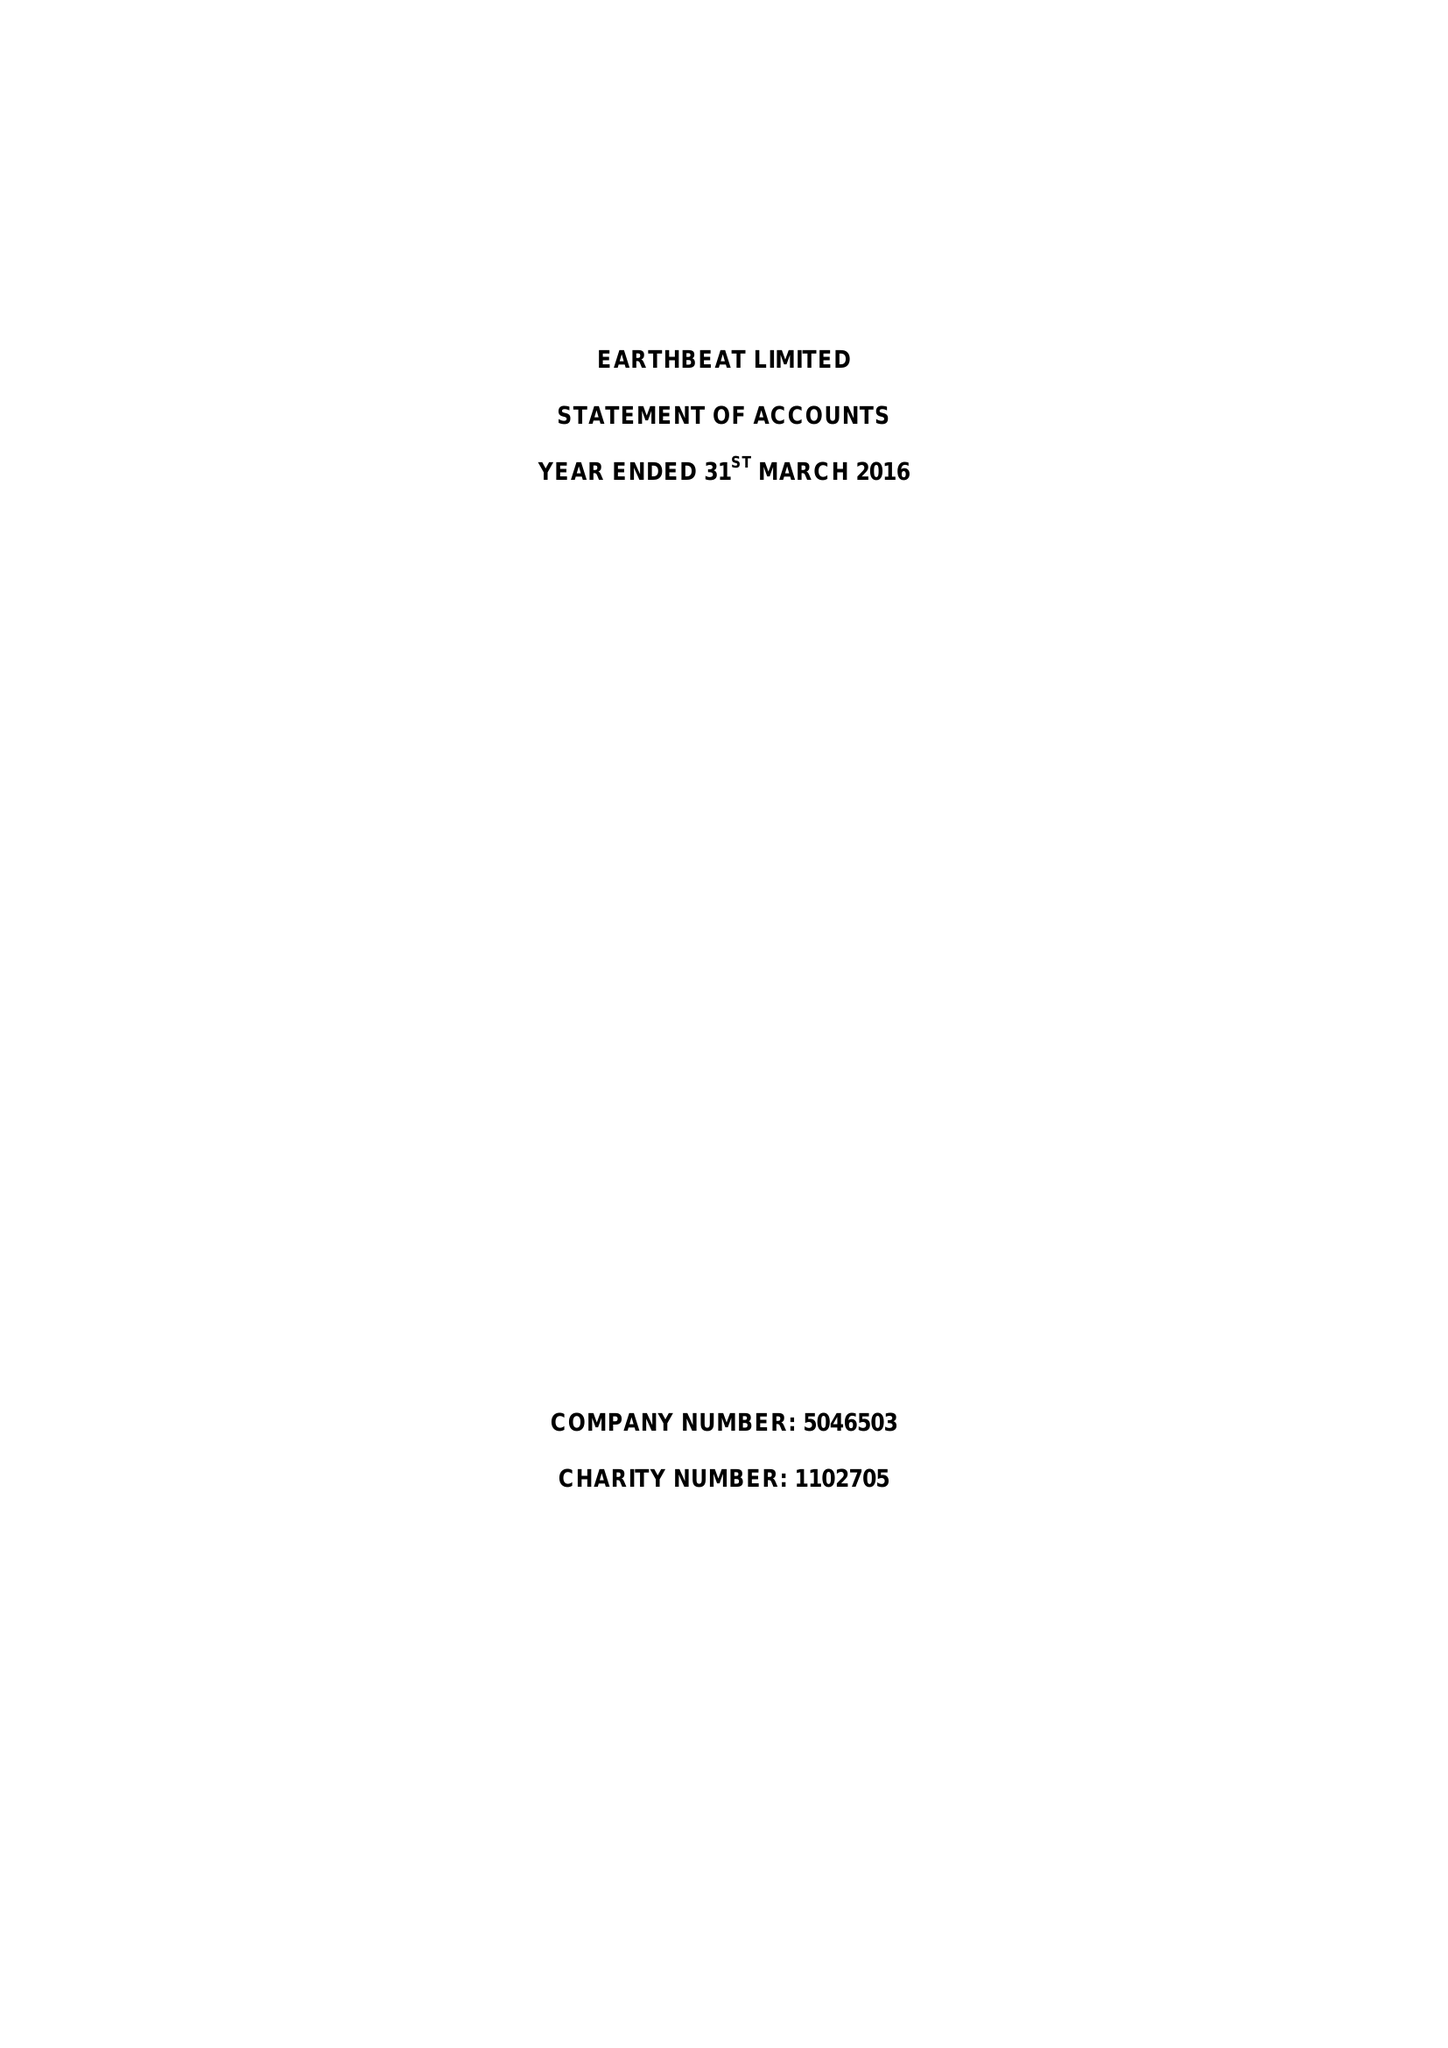What is the value for the address__postcode?
Answer the question using a single word or phrase. TS11 7AQ 